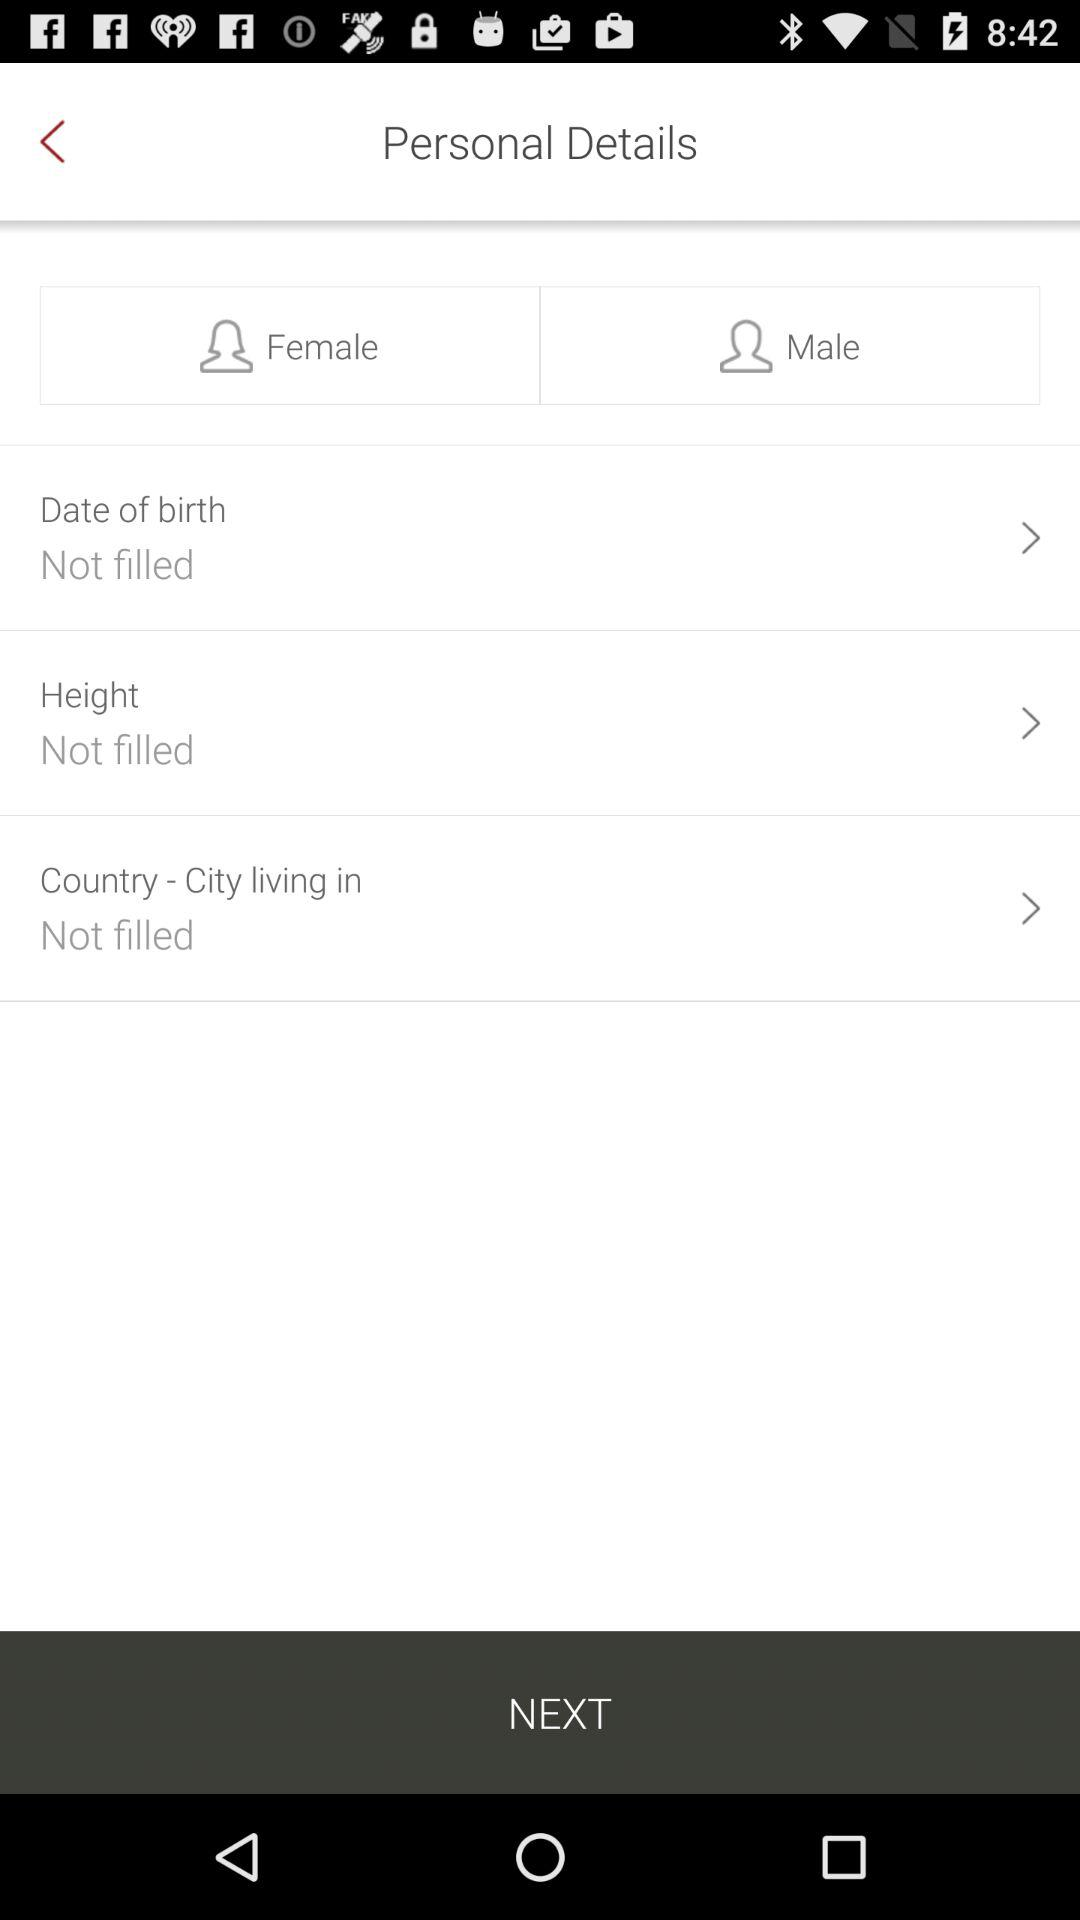What is the gender? The genders are female and male. 